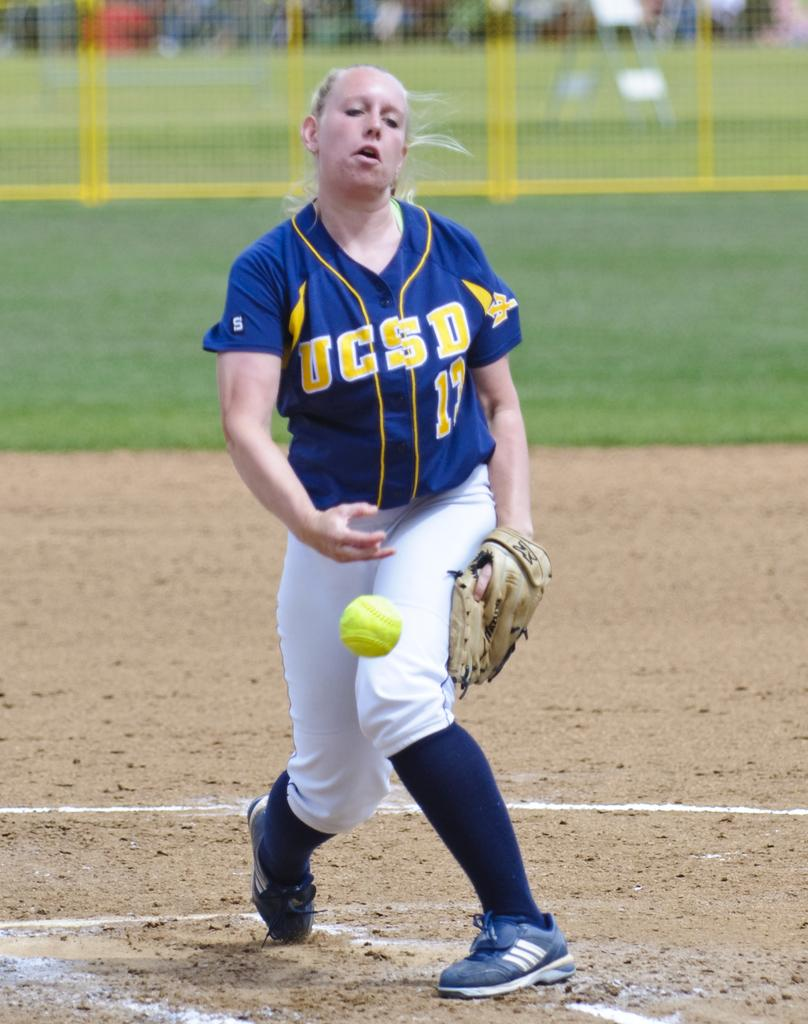Provide a one-sentence caption for the provided image. A pitcher from UCSD tosses the ball from the mound. 